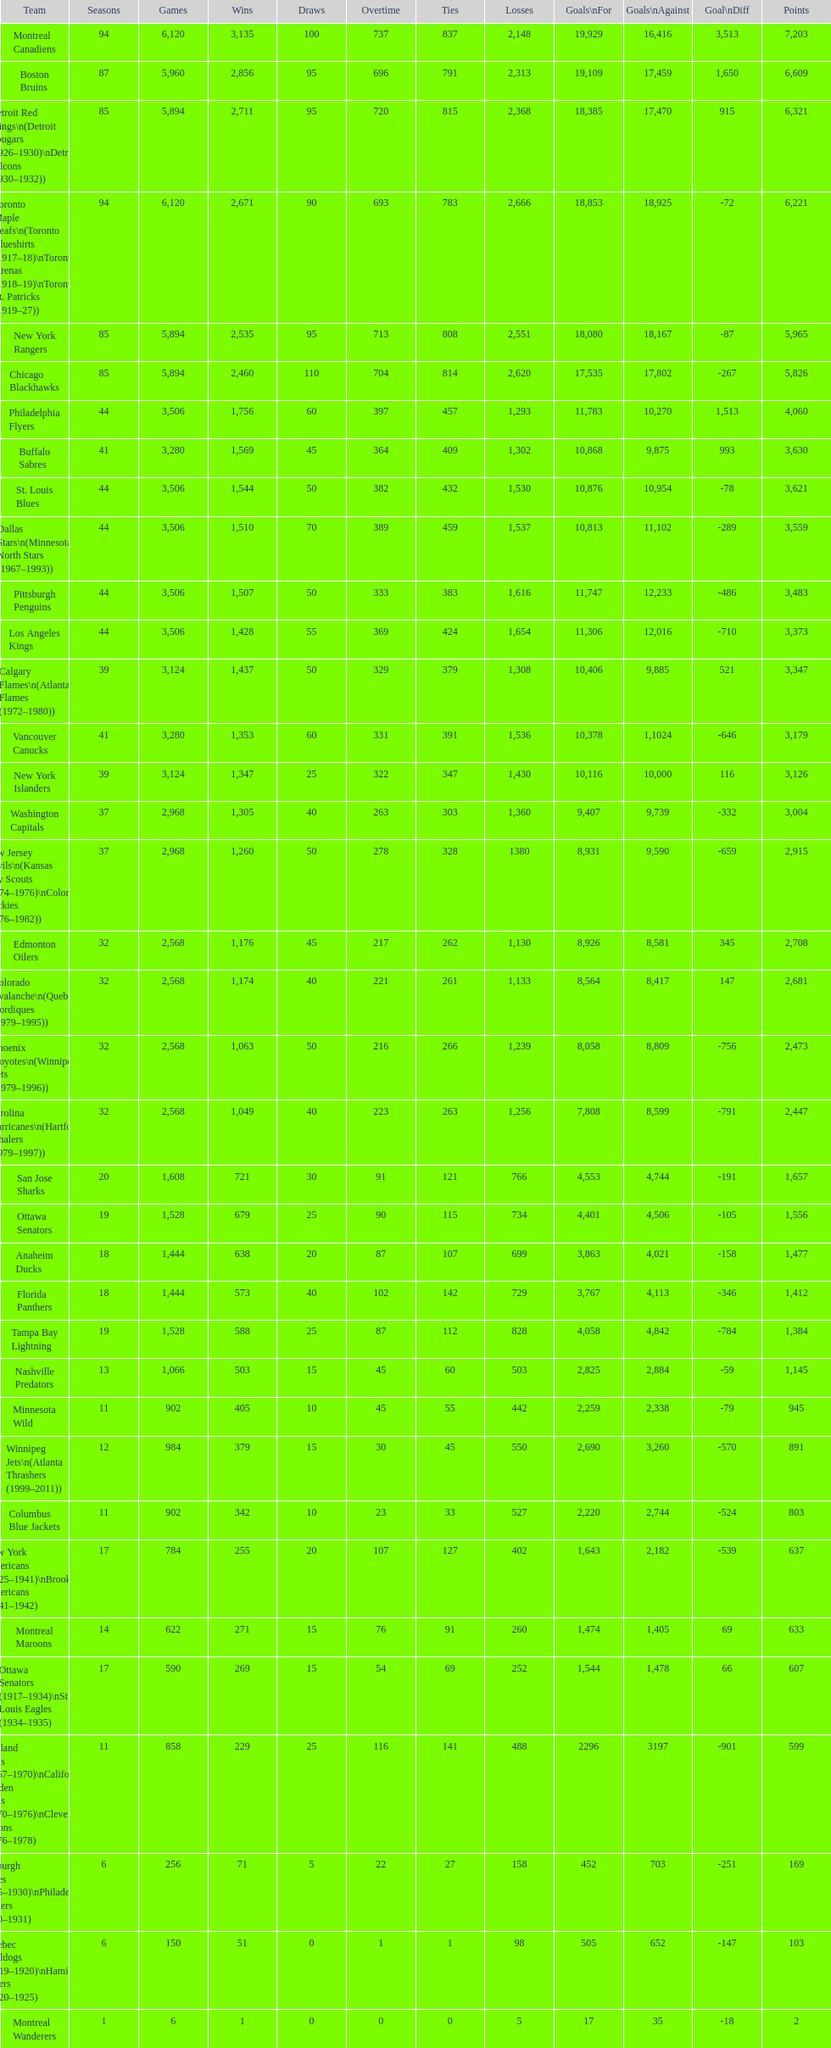Can you give me this table as a dict? {'header': ['Team', 'Seasons', 'Games', 'Wins', 'Draws', 'Overtime', 'Ties', 'Losses', 'Goals\\nFor', 'Goals\\nAgainst', 'Goal\\nDiff', 'Points'], 'rows': [['Montreal Canadiens', '94', '6,120', '3,135', '100', '737', '837', '2,148', '19,929', '16,416', '3,513', '7,203'], ['Boston Bruins', '87', '5,960', '2,856', '95', '696', '791', '2,313', '19,109', '17,459', '1,650', '6,609'], ['Detroit Red Wings\\n(Detroit Cougars (1926–1930)\\nDetroit Falcons (1930–1932))', '85', '5,894', '2,711', '95', '720', '815', '2,368', '18,385', '17,470', '915', '6,321'], ['Toronto Maple Leafs\\n(Toronto Blueshirts (1917–18)\\nToronto Arenas (1918–19)\\nToronto St. Patricks (1919–27))', '94', '6,120', '2,671', '90', '693', '783', '2,666', '18,853', '18,925', '-72', '6,221'], ['New York Rangers', '85', '5,894', '2,535', '95', '713', '808', '2,551', '18,080', '18,167', '-87', '5,965'], ['Chicago Blackhawks', '85', '5,894', '2,460', '110', '704', '814', '2,620', '17,535', '17,802', '-267', '5,826'], ['Philadelphia Flyers', '44', '3,506', '1,756', '60', '397', '457', '1,293', '11,783', '10,270', '1,513', '4,060'], ['Buffalo Sabres', '41', '3,280', '1,569', '45', '364', '409', '1,302', '10,868', '9,875', '993', '3,630'], ['St. Louis Blues', '44', '3,506', '1,544', '50', '382', '432', '1,530', '10,876', '10,954', '-78', '3,621'], ['Dallas Stars\\n(Minnesota North Stars (1967–1993))', '44', '3,506', '1,510', '70', '389', '459', '1,537', '10,813', '11,102', '-289', '3,559'], ['Pittsburgh Penguins', '44', '3,506', '1,507', '50', '333', '383', '1,616', '11,747', '12,233', '-486', '3,483'], ['Los Angeles Kings', '44', '3,506', '1,428', '55', '369', '424', '1,654', '11,306', '12,016', '-710', '3,373'], ['Calgary Flames\\n(Atlanta Flames (1972–1980))', '39', '3,124', '1,437', '50', '329', '379', '1,308', '10,406', '9,885', '521', '3,347'], ['Vancouver Canucks', '41', '3,280', '1,353', '60', '331', '391', '1,536', '10,378', '1,1024', '-646', '3,179'], ['New York Islanders', '39', '3,124', '1,347', '25', '322', '347', '1,430', '10,116', '10,000', '116', '3,126'], ['Washington Capitals', '37', '2,968', '1,305', '40', '263', '303', '1,360', '9,407', '9,739', '-332', '3,004'], ['New Jersey Devils\\n(Kansas City Scouts (1974–1976)\\nColorado Rockies (1976–1982))', '37', '2,968', '1,260', '50', '278', '328', '1380', '8,931', '9,590', '-659', '2,915'], ['Edmonton Oilers', '32', '2,568', '1,176', '45', '217', '262', '1,130', '8,926', '8,581', '345', '2,708'], ['Colorado Avalanche\\n(Quebec Nordiques (1979–1995))', '32', '2,568', '1,174', '40', '221', '261', '1,133', '8,564', '8,417', '147', '2,681'], ['Phoenix Coyotes\\n(Winnipeg Jets (1979–1996))', '32', '2,568', '1,063', '50', '216', '266', '1,239', '8,058', '8,809', '-756', '2,473'], ['Carolina Hurricanes\\n(Hartford Whalers (1979–1997))', '32', '2,568', '1,049', '40', '223', '263', '1,256', '7,808', '8,599', '-791', '2,447'], ['San Jose Sharks', '20', '1,608', '721', '30', '91', '121', '766', '4,553', '4,744', '-191', '1,657'], ['Ottawa Senators', '19', '1,528', '679', '25', '90', '115', '734', '4,401', '4,506', '-105', '1,556'], ['Anaheim Ducks', '18', '1,444', '638', '20', '87', '107', '699', '3,863', '4,021', '-158', '1,477'], ['Florida Panthers', '18', '1,444', '573', '40', '102', '142', '729', '3,767', '4,113', '-346', '1,412'], ['Tampa Bay Lightning', '19', '1,528', '588', '25', '87', '112', '828', '4,058', '4,842', '-784', '1,384'], ['Nashville Predators', '13', '1,066', '503', '15', '45', '60', '503', '2,825', '2,884', '-59', '1,145'], ['Minnesota Wild', '11', '902', '405', '10', '45', '55', '442', '2,259', '2,338', '-79', '945'], ['Winnipeg Jets\\n(Atlanta Thrashers (1999–2011))', '12', '984', '379', '15', '30', '45', '550', '2,690', '3,260', '-570', '891'], ['Columbus Blue Jackets', '11', '902', '342', '10', '23', '33', '527', '2,220', '2,744', '-524', '803'], ['New York Americans (1925–1941)\\nBrooklyn Americans (1941–1942)', '17', '784', '255', '20', '107', '127', '402', '1,643', '2,182', '-539', '637'], ['Montreal Maroons', '14', '622', '271', '15', '76', '91', '260', '1,474', '1,405', '69', '633'], ['Ottawa Senators (1917–1934)\\nSt. Louis Eagles (1934–1935)', '17', '590', '269', '15', '54', '69', '252', '1,544', '1,478', '66', '607'], ['Oakland Seals (1967–1970)\\nCalifornia Golden Seals (1970–1976)\\nCleveland Barons (1976–1978)', '11', '858', '229', '25', '116', '141', '488', '2296', '3197', '-901', '599'], ['Pittsburgh Pirates (1925–1930)\\nPhiladelphia Quakers (1930–1931)', '6', '256', '71', '5', '22', '27', '158', '452', '703', '-251', '169'], ['Quebec Bulldogs (1919–1920)\\nHamilton Tigers (1920–1925)', '6', '150', '51', '0', '1', '1', '98', '505', '652', '-147', '103'], ['Montreal Wanderers', '1', '6', '1', '0', '0', '0', '5', '17', '35', '-18', '2']]} How many total points has the lost angeles kings scored? 3,373. 